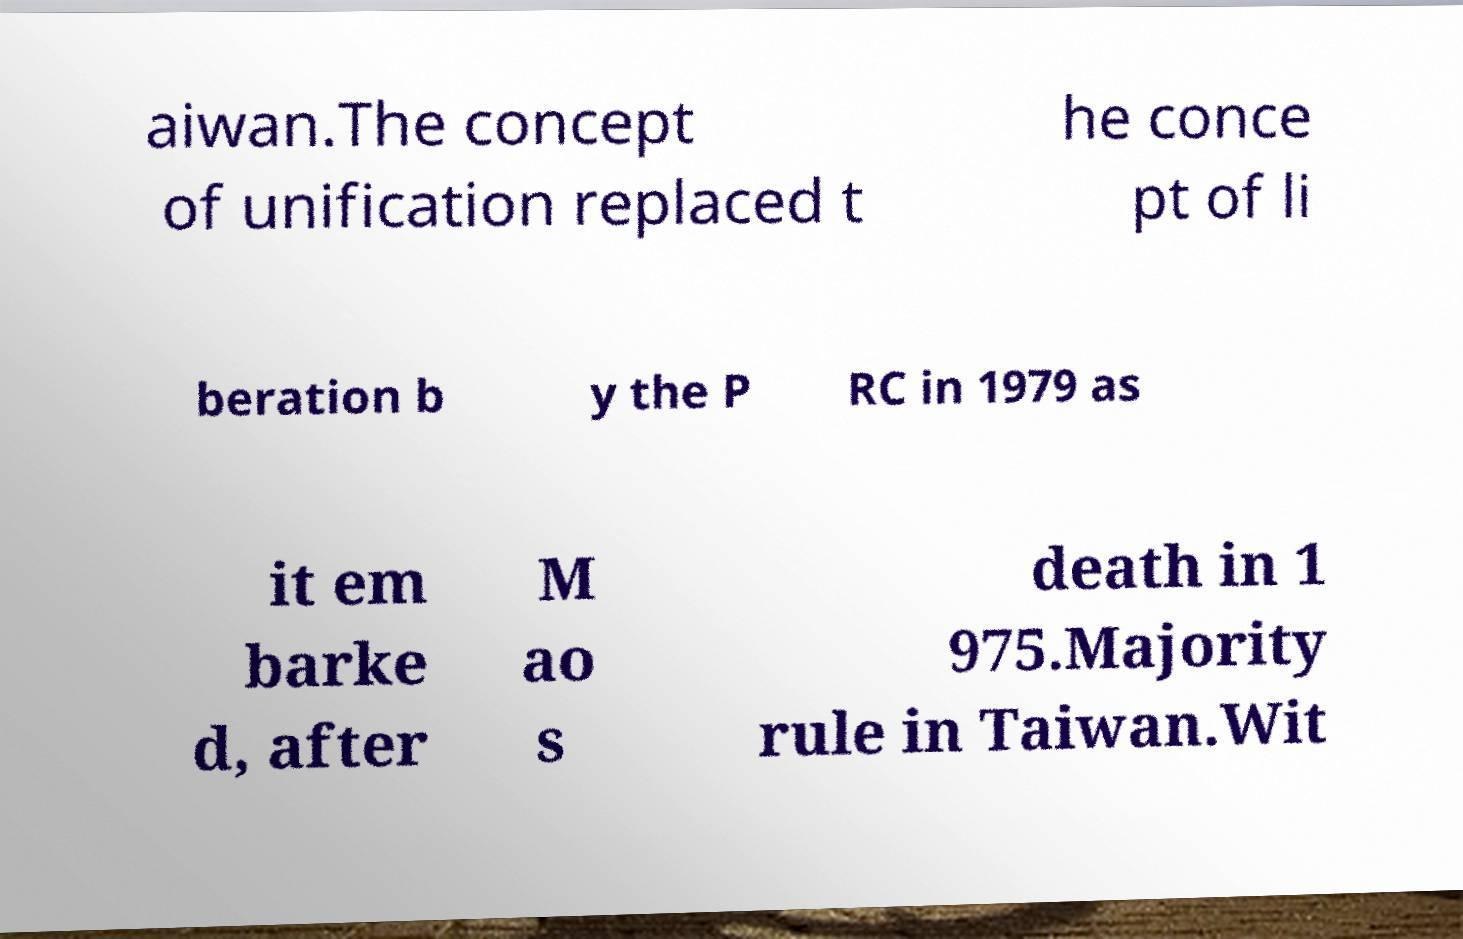There's text embedded in this image that I need extracted. Can you transcribe it verbatim? aiwan.The concept of unification replaced t he conce pt of li beration b y the P RC in 1979 as it em barke d, after M ao s death in 1 975.Majority rule in Taiwan.Wit 